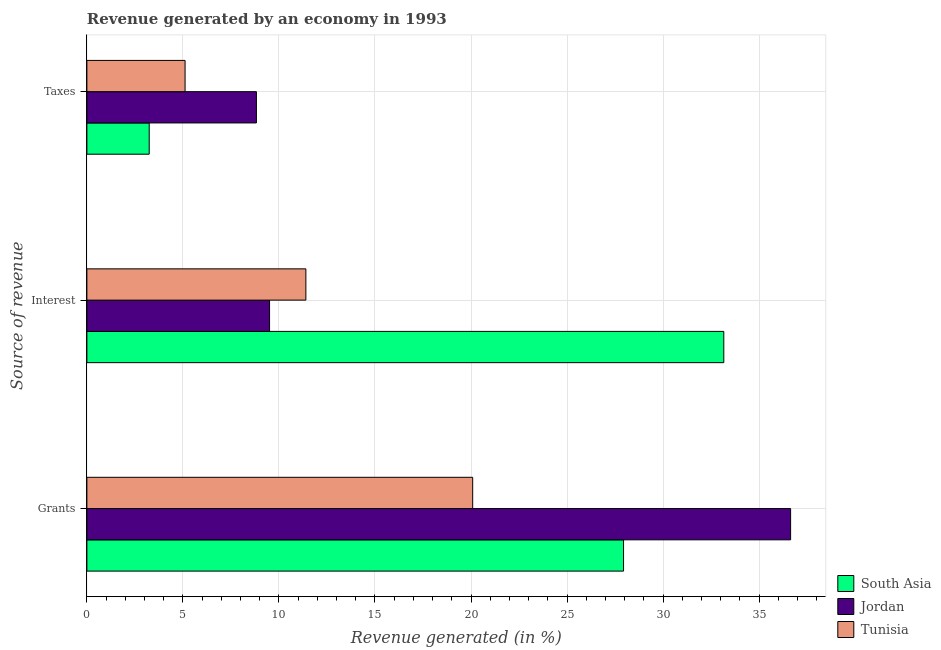Are the number of bars per tick equal to the number of legend labels?
Keep it short and to the point. Yes. Are the number of bars on each tick of the Y-axis equal?
Your response must be concise. Yes. How many bars are there on the 3rd tick from the top?
Your answer should be compact. 3. How many bars are there on the 3rd tick from the bottom?
Offer a very short reply. 3. What is the label of the 2nd group of bars from the top?
Your answer should be compact. Interest. What is the percentage of revenue generated by taxes in Jordan?
Keep it short and to the point. 8.83. Across all countries, what is the maximum percentage of revenue generated by grants?
Your answer should be compact. 36.64. Across all countries, what is the minimum percentage of revenue generated by grants?
Your answer should be compact. 20.09. In which country was the percentage of revenue generated by taxes maximum?
Ensure brevity in your answer.  Jordan. In which country was the percentage of revenue generated by interest minimum?
Your response must be concise. Jordan. What is the total percentage of revenue generated by taxes in the graph?
Offer a terse response. 17.19. What is the difference between the percentage of revenue generated by taxes in Tunisia and that in Jordan?
Offer a terse response. -3.72. What is the difference between the percentage of revenue generated by grants in Jordan and the percentage of revenue generated by interest in South Asia?
Keep it short and to the point. 3.48. What is the average percentage of revenue generated by interest per country?
Your answer should be very brief. 18.03. What is the difference between the percentage of revenue generated by interest and percentage of revenue generated by grants in Tunisia?
Your response must be concise. -8.69. What is the ratio of the percentage of revenue generated by interest in South Asia to that in Tunisia?
Your answer should be very brief. 2.91. Is the percentage of revenue generated by interest in South Asia less than that in Tunisia?
Provide a succinct answer. No. What is the difference between the highest and the second highest percentage of revenue generated by grants?
Offer a terse response. 8.7. What is the difference between the highest and the lowest percentage of revenue generated by taxes?
Your answer should be compact. 5.58. What does the 1st bar from the top in Taxes represents?
Your answer should be compact. Tunisia. What does the 1st bar from the bottom in Taxes represents?
Give a very brief answer. South Asia. Are all the bars in the graph horizontal?
Offer a terse response. Yes. How many countries are there in the graph?
Provide a short and direct response. 3. What is the difference between two consecutive major ticks on the X-axis?
Offer a terse response. 5. Are the values on the major ticks of X-axis written in scientific E-notation?
Your response must be concise. No. Does the graph contain any zero values?
Make the answer very short. No. How are the legend labels stacked?
Your answer should be compact. Vertical. What is the title of the graph?
Offer a terse response. Revenue generated by an economy in 1993. Does "Vanuatu" appear as one of the legend labels in the graph?
Make the answer very short. No. What is the label or title of the X-axis?
Your answer should be compact. Revenue generated (in %). What is the label or title of the Y-axis?
Offer a very short reply. Source of revenue. What is the Revenue generated (in %) of South Asia in Grants?
Keep it short and to the point. 27.94. What is the Revenue generated (in %) of Jordan in Grants?
Offer a terse response. 36.64. What is the Revenue generated (in %) in Tunisia in Grants?
Keep it short and to the point. 20.09. What is the Revenue generated (in %) in South Asia in Interest?
Offer a terse response. 33.16. What is the Revenue generated (in %) in Jordan in Interest?
Offer a very short reply. 9.51. What is the Revenue generated (in %) in Tunisia in Interest?
Provide a succinct answer. 11.4. What is the Revenue generated (in %) in South Asia in Taxes?
Keep it short and to the point. 3.24. What is the Revenue generated (in %) of Jordan in Taxes?
Keep it short and to the point. 8.83. What is the Revenue generated (in %) of Tunisia in Taxes?
Keep it short and to the point. 5.11. Across all Source of revenue, what is the maximum Revenue generated (in %) in South Asia?
Offer a very short reply. 33.16. Across all Source of revenue, what is the maximum Revenue generated (in %) in Jordan?
Ensure brevity in your answer.  36.64. Across all Source of revenue, what is the maximum Revenue generated (in %) of Tunisia?
Provide a succinct answer. 20.09. Across all Source of revenue, what is the minimum Revenue generated (in %) in South Asia?
Offer a terse response. 3.24. Across all Source of revenue, what is the minimum Revenue generated (in %) in Jordan?
Keep it short and to the point. 8.83. Across all Source of revenue, what is the minimum Revenue generated (in %) in Tunisia?
Provide a succinct answer. 5.11. What is the total Revenue generated (in %) of South Asia in the graph?
Ensure brevity in your answer.  64.35. What is the total Revenue generated (in %) in Jordan in the graph?
Offer a terse response. 54.98. What is the total Revenue generated (in %) of Tunisia in the graph?
Keep it short and to the point. 36.6. What is the difference between the Revenue generated (in %) in South Asia in Grants and that in Interest?
Your answer should be very brief. -5.22. What is the difference between the Revenue generated (in %) of Jordan in Grants and that in Interest?
Your answer should be compact. 27.13. What is the difference between the Revenue generated (in %) in Tunisia in Grants and that in Interest?
Make the answer very short. 8.69. What is the difference between the Revenue generated (in %) of South Asia in Grants and that in Taxes?
Keep it short and to the point. 24.7. What is the difference between the Revenue generated (in %) in Jordan in Grants and that in Taxes?
Your answer should be compact. 27.81. What is the difference between the Revenue generated (in %) in Tunisia in Grants and that in Taxes?
Ensure brevity in your answer.  14.98. What is the difference between the Revenue generated (in %) of South Asia in Interest and that in Taxes?
Give a very brief answer. 29.92. What is the difference between the Revenue generated (in %) of Jordan in Interest and that in Taxes?
Provide a succinct answer. 0.68. What is the difference between the Revenue generated (in %) of Tunisia in Interest and that in Taxes?
Give a very brief answer. 6.29. What is the difference between the Revenue generated (in %) of South Asia in Grants and the Revenue generated (in %) of Jordan in Interest?
Offer a very short reply. 18.43. What is the difference between the Revenue generated (in %) of South Asia in Grants and the Revenue generated (in %) of Tunisia in Interest?
Offer a terse response. 16.54. What is the difference between the Revenue generated (in %) of Jordan in Grants and the Revenue generated (in %) of Tunisia in Interest?
Give a very brief answer. 25.24. What is the difference between the Revenue generated (in %) in South Asia in Grants and the Revenue generated (in %) in Jordan in Taxes?
Make the answer very short. 19.11. What is the difference between the Revenue generated (in %) in South Asia in Grants and the Revenue generated (in %) in Tunisia in Taxes?
Ensure brevity in your answer.  22.83. What is the difference between the Revenue generated (in %) in Jordan in Grants and the Revenue generated (in %) in Tunisia in Taxes?
Your response must be concise. 31.53. What is the difference between the Revenue generated (in %) of South Asia in Interest and the Revenue generated (in %) of Jordan in Taxes?
Your response must be concise. 24.33. What is the difference between the Revenue generated (in %) in South Asia in Interest and the Revenue generated (in %) in Tunisia in Taxes?
Your response must be concise. 28.05. What is the difference between the Revenue generated (in %) of Jordan in Interest and the Revenue generated (in %) of Tunisia in Taxes?
Keep it short and to the point. 4.4. What is the average Revenue generated (in %) of South Asia per Source of revenue?
Your answer should be compact. 21.45. What is the average Revenue generated (in %) of Jordan per Source of revenue?
Your answer should be very brief. 18.33. What is the average Revenue generated (in %) of Tunisia per Source of revenue?
Make the answer very short. 12.2. What is the difference between the Revenue generated (in %) in South Asia and Revenue generated (in %) in Jordan in Grants?
Your response must be concise. -8.7. What is the difference between the Revenue generated (in %) of South Asia and Revenue generated (in %) of Tunisia in Grants?
Give a very brief answer. 7.85. What is the difference between the Revenue generated (in %) in Jordan and Revenue generated (in %) in Tunisia in Grants?
Make the answer very short. 16.55. What is the difference between the Revenue generated (in %) in South Asia and Revenue generated (in %) in Jordan in Interest?
Your response must be concise. 23.65. What is the difference between the Revenue generated (in %) in South Asia and Revenue generated (in %) in Tunisia in Interest?
Offer a very short reply. 21.76. What is the difference between the Revenue generated (in %) of Jordan and Revenue generated (in %) of Tunisia in Interest?
Your response must be concise. -1.89. What is the difference between the Revenue generated (in %) of South Asia and Revenue generated (in %) of Jordan in Taxes?
Offer a very short reply. -5.58. What is the difference between the Revenue generated (in %) in South Asia and Revenue generated (in %) in Tunisia in Taxes?
Give a very brief answer. -1.87. What is the difference between the Revenue generated (in %) in Jordan and Revenue generated (in %) in Tunisia in Taxes?
Your response must be concise. 3.72. What is the ratio of the Revenue generated (in %) of South Asia in Grants to that in Interest?
Keep it short and to the point. 0.84. What is the ratio of the Revenue generated (in %) of Jordan in Grants to that in Interest?
Make the answer very short. 3.85. What is the ratio of the Revenue generated (in %) in Tunisia in Grants to that in Interest?
Keep it short and to the point. 1.76. What is the ratio of the Revenue generated (in %) of South Asia in Grants to that in Taxes?
Offer a very short reply. 8.61. What is the ratio of the Revenue generated (in %) of Jordan in Grants to that in Taxes?
Your response must be concise. 4.15. What is the ratio of the Revenue generated (in %) in Tunisia in Grants to that in Taxes?
Your response must be concise. 3.93. What is the ratio of the Revenue generated (in %) in South Asia in Interest to that in Taxes?
Your answer should be very brief. 10.22. What is the ratio of the Revenue generated (in %) in Jordan in Interest to that in Taxes?
Provide a short and direct response. 1.08. What is the ratio of the Revenue generated (in %) of Tunisia in Interest to that in Taxes?
Offer a terse response. 2.23. What is the difference between the highest and the second highest Revenue generated (in %) in South Asia?
Provide a short and direct response. 5.22. What is the difference between the highest and the second highest Revenue generated (in %) in Jordan?
Your response must be concise. 27.13. What is the difference between the highest and the second highest Revenue generated (in %) in Tunisia?
Keep it short and to the point. 8.69. What is the difference between the highest and the lowest Revenue generated (in %) in South Asia?
Your response must be concise. 29.92. What is the difference between the highest and the lowest Revenue generated (in %) in Jordan?
Ensure brevity in your answer.  27.81. What is the difference between the highest and the lowest Revenue generated (in %) of Tunisia?
Make the answer very short. 14.98. 